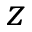Convert formula to latex. <formula><loc_0><loc_0><loc_500><loc_500>z</formula> 